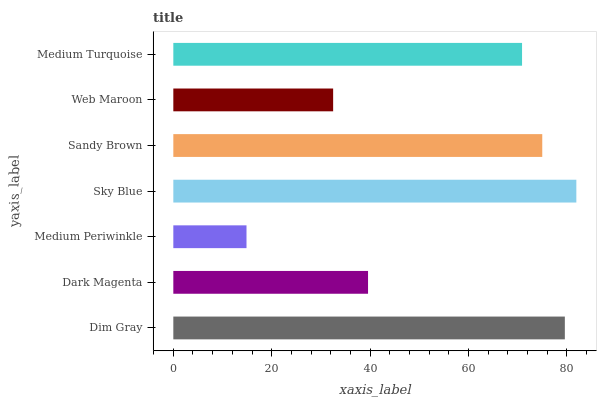Is Medium Periwinkle the minimum?
Answer yes or no. Yes. Is Sky Blue the maximum?
Answer yes or no. Yes. Is Dark Magenta the minimum?
Answer yes or no. No. Is Dark Magenta the maximum?
Answer yes or no. No. Is Dim Gray greater than Dark Magenta?
Answer yes or no. Yes. Is Dark Magenta less than Dim Gray?
Answer yes or no. Yes. Is Dark Magenta greater than Dim Gray?
Answer yes or no. No. Is Dim Gray less than Dark Magenta?
Answer yes or no. No. Is Medium Turquoise the high median?
Answer yes or no. Yes. Is Medium Turquoise the low median?
Answer yes or no. Yes. Is Sky Blue the high median?
Answer yes or no. No. Is Sandy Brown the low median?
Answer yes or no. No. 